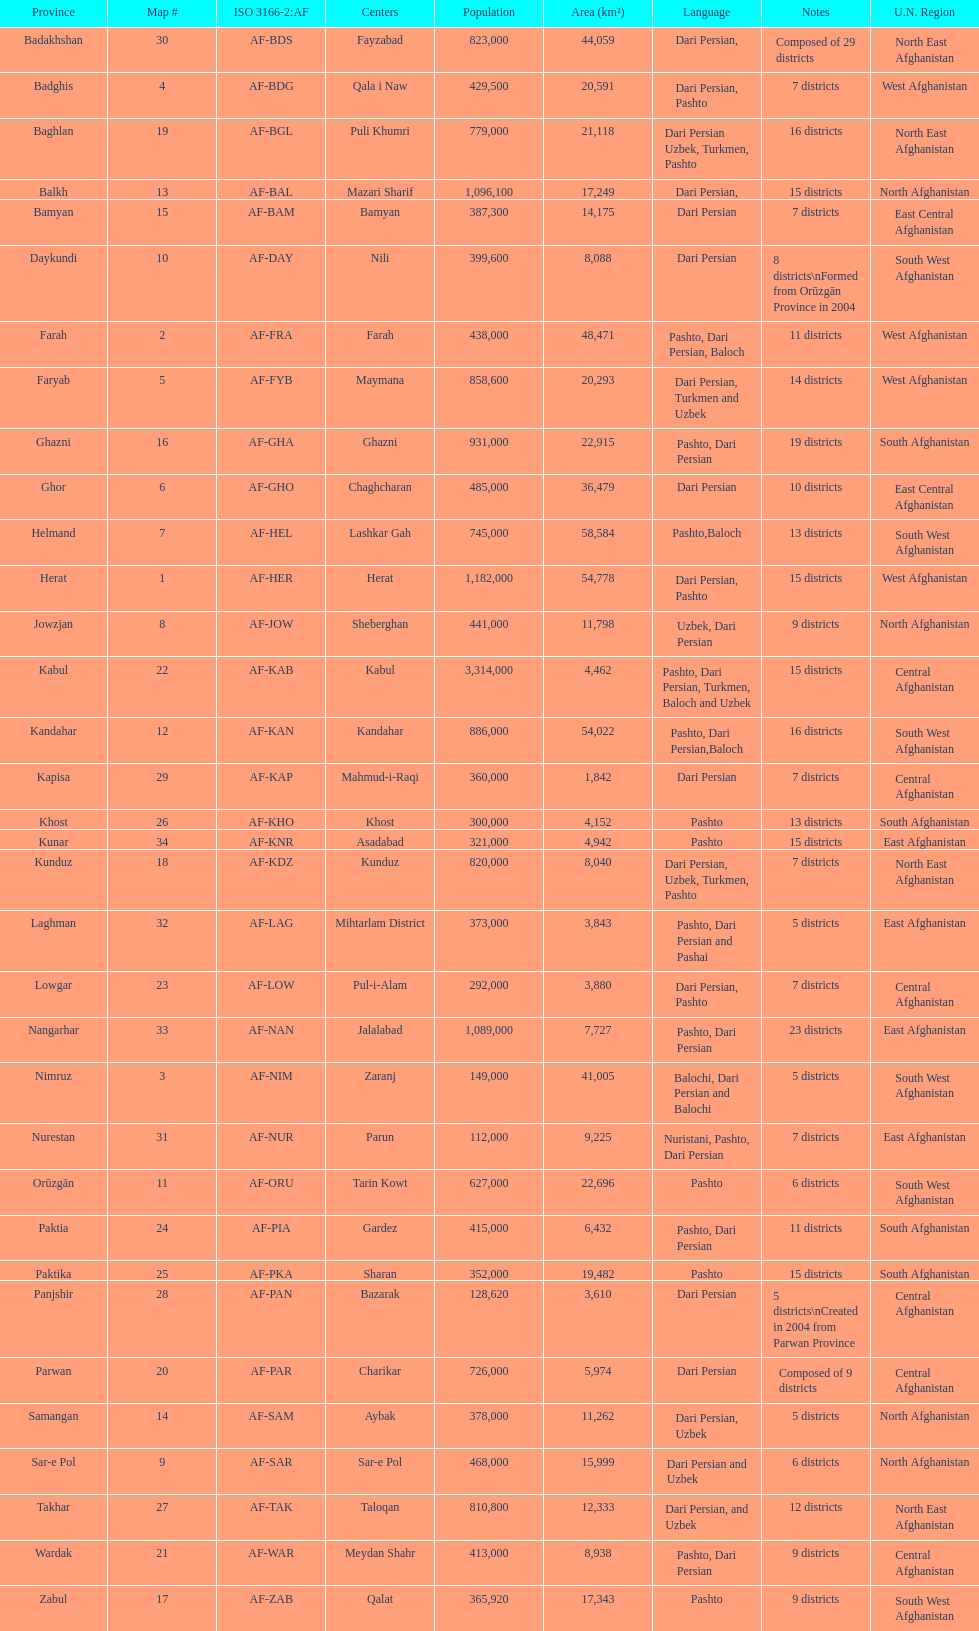How many provinces have pashto as one of their languages 20. 